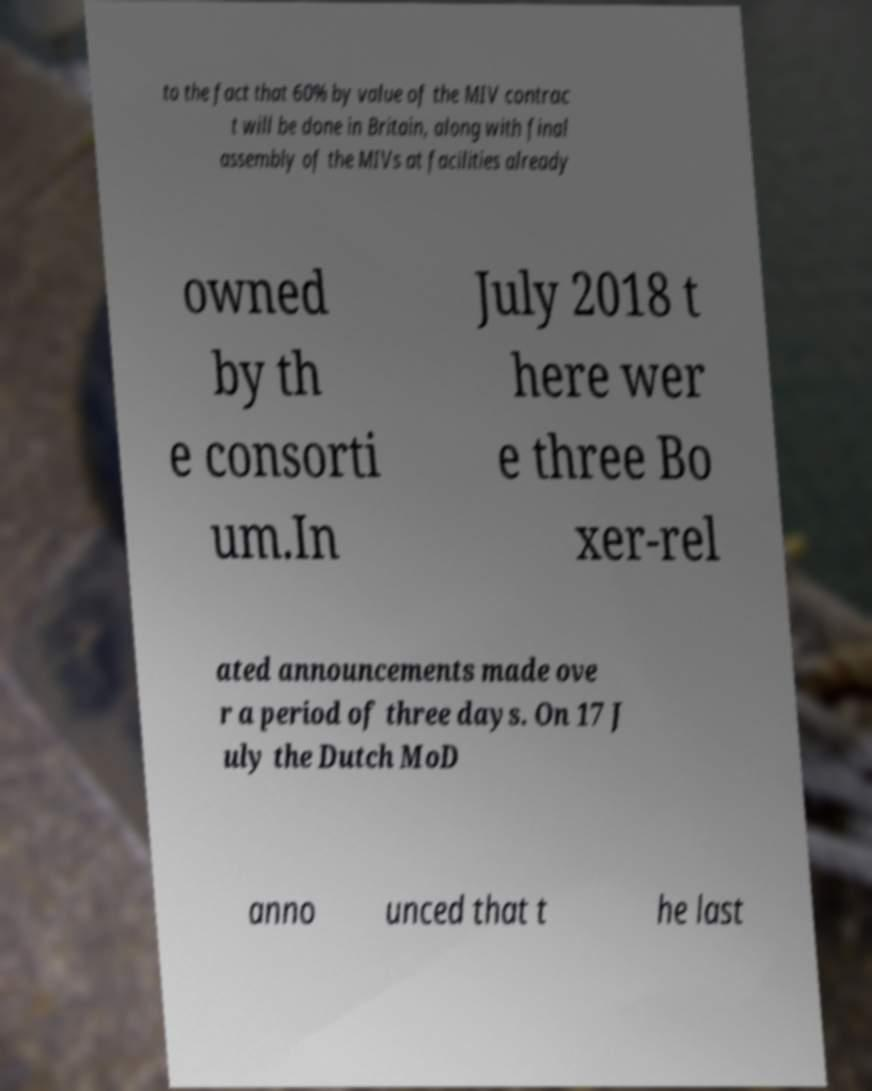Could you assist in decoding the text presented in this image and type it out clearly? to the fact that 60% by value of the MIV contrac t will be done in Britain, along with final assembly of the MIVs at facilities already owned by th e consorti um.In July 2018 t here wer e three Bo xer-rel ated announcements made ove r a period of three days. On 17 J uly the Dutch MoD anno unced that t he last 